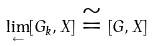Convert formula to latex. <formula><loc_0><loc_0><loc_500><loc_500>\underset { \leftarrow } { \lim } [ G _ { k } , X ] \cong [ G , X ]</formula> 